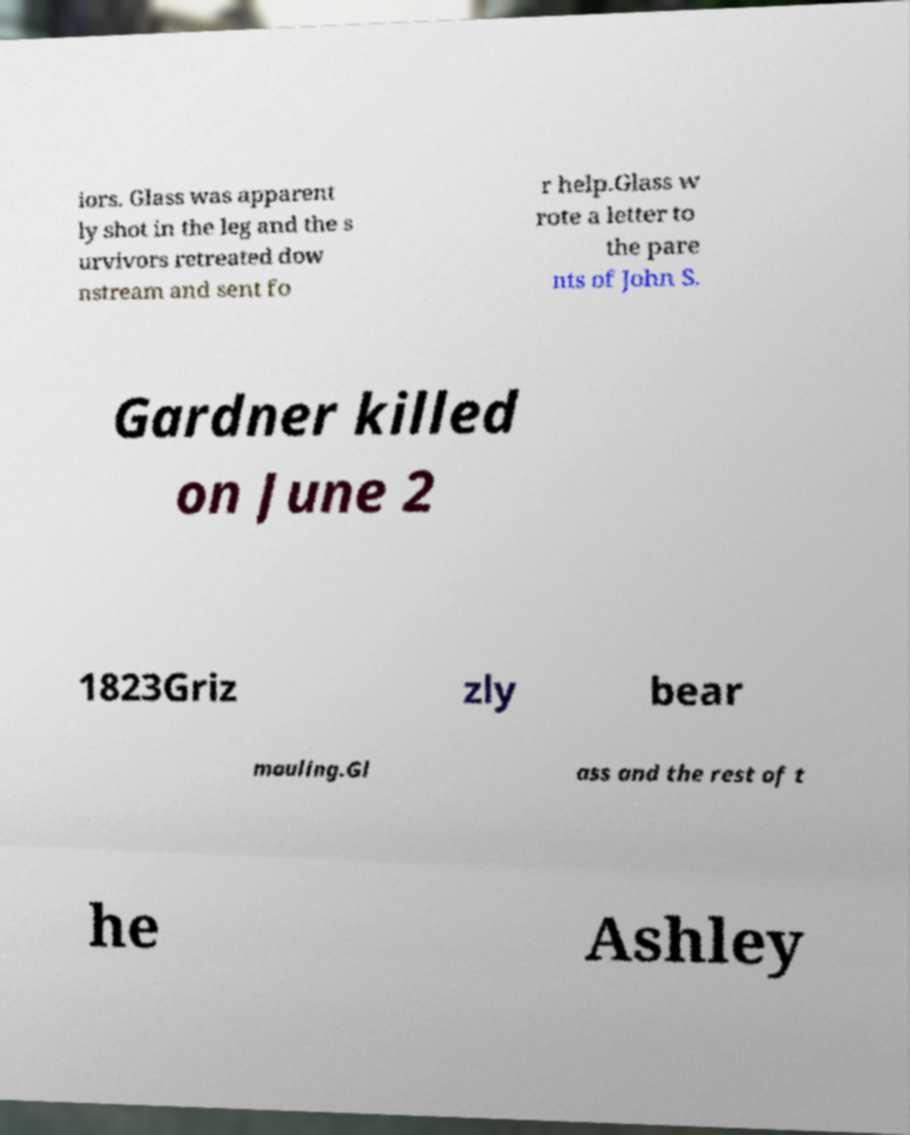What messages or text are displayed in this image? I need them in a readable, typed format. iors. Glass was apparent ly shot in the leg and the s urvivors retreated dow nstream and sent fo r help.Glass w rote a letter to the pare nts of John S. Gardner killed on June 2 1823Griz zly bear mauling.Gl ass and the rest of t he Ashley 